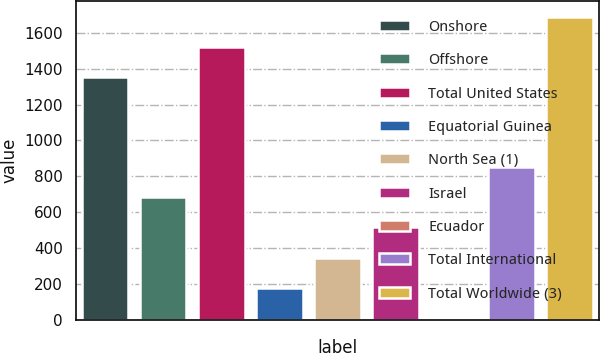Convert chart to OTSL. <chart><loc_0><loc_0><loc_500><loc_500><bar_chart><fcel>Onshore<fcel>Offshore<fcel>Total United States<fcel>Equatorial Guinea<fcel>North Sea (1)<fcel>Israel<fcel>Ecuador<fcel>Total International<fcel>Total Worldwide (3)<nl><fcel>1352<fcel>683.2<fcel>1519.8<fcel>179.8<fcel>347.6<fcel>515.4<fcel>12<fcel>851<fcel>1690<nl></chart> 